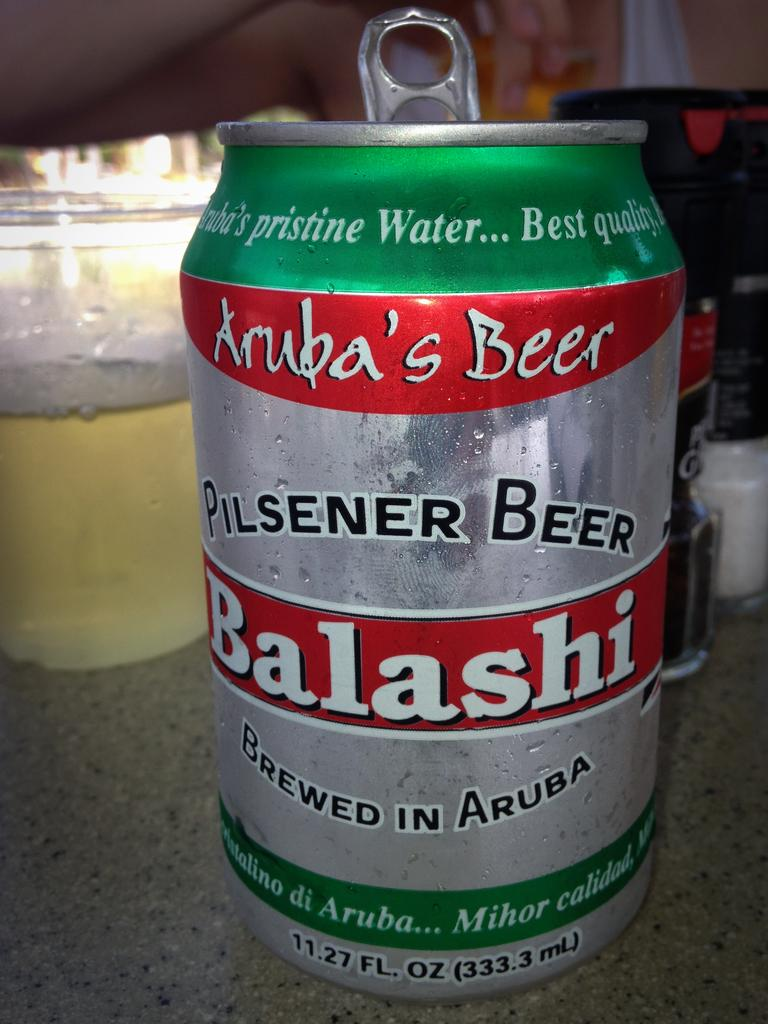<image>
Describe the image concisely. A silver, green , and red  can of Pilsener beer  brewed in Aruba. 